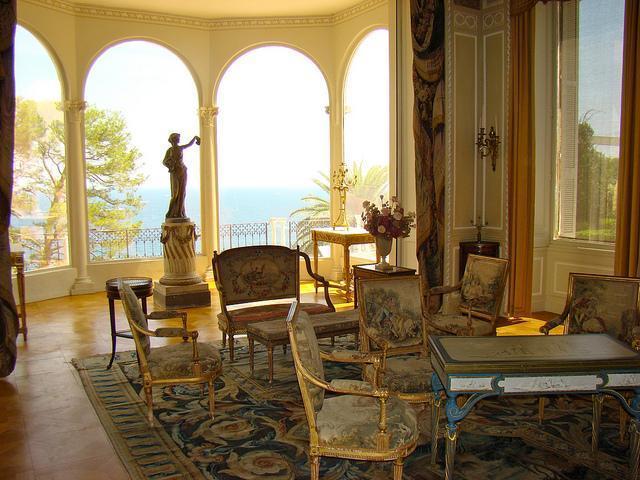How many chairs are in the picture?
Give a very brief answer. 6. How many chairs can you see?
Give a very brief answer. 6. How many dining tables are visible?
Give a very brief answer. 2. How many people are wearing a catchers helmet in the image?
Give a very brief answer. 0. 